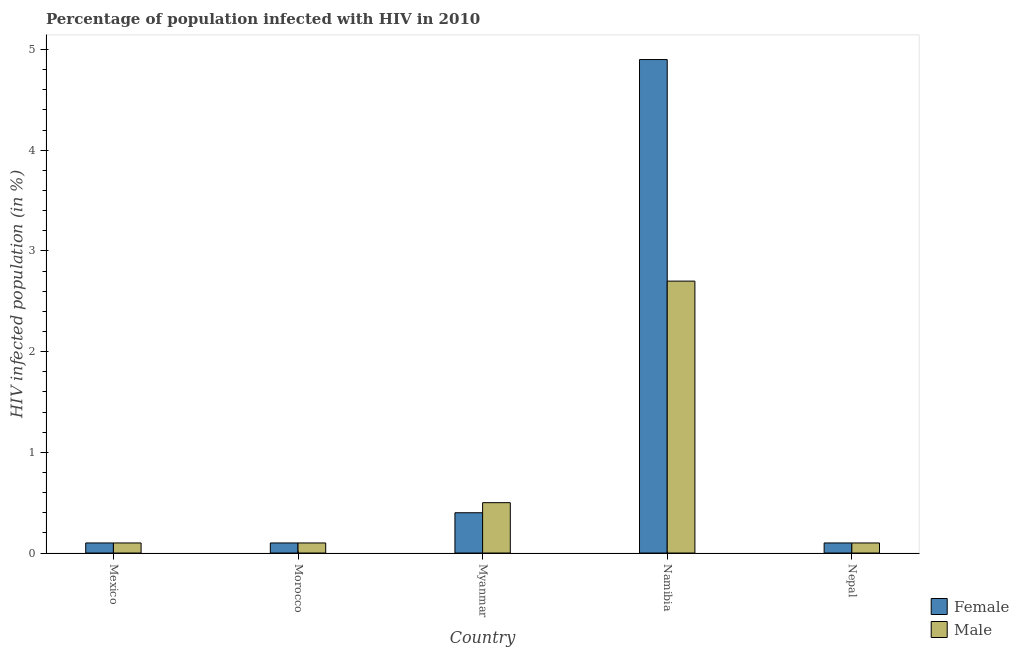How many different coloured bars are there?
Keep it short and to the point. 2. Are the number of bars per tick equal to the number of legend labels?
Your answer should be very brief. Yes. How many bars are there on the 4th tick from the left?
Provide a succinct answer. 2. How many bars are there on the 4th tick from the right?
Ensure brevity in your answer.  2. What is the label of the 4th group of bars from the left?
Offer a very short reply. Namibia. In how many cases, is the number of bars for a given country not equal to the number of legend labels?
Provide a short and direct response. 0. What is the percentage of females who are infected with hiv in Nepal?
Ensure brevity in your answer.  0.1. In which country was the percentage of females who are infected with hiv maximum?
Your response must be concise. Namibia. In which country was the percentage of females who are infected with hiv minimum?
Provide a succinct answer. Mexico. What is the average percentage of males who are infected with hiv per country?
Provide a short and direct response. 0.7. What is the difference between the percentage of females who are infected with hiv and percentage of males who are infected with hiv in Nepal?
Your response must be concise. 0. In how many countries, is the percentage of males who are infected with hiv greater than 0.6000000000000001 %?
Ensure brevity in your answer.  1. What is the ratio of the percentage of females who are infected with hiv in Mexico to that in Nepal?
Provide a short and direct response. 1. Is the difference between the percentage of females who are infected with hiv in Mexico and Morocco greater than the difference between the percentage of males who are infected with hiv in Mexico and Morocco?
Offer a terse response. No. In how many countries, is the percentage of males who are infected with hiv greater than the average percentage of males who are infected with hiv taken over all countries?
Your answer should be compact. 1. How many bars are there?
Your response must be concise. 10. What is the difference between two consecutive major ticks on the Y-axis?
Ensure brevity in your answer.  1. Does the graph contain any zero values?
Provide a succinct answer. No. How many legend labels are there?
Offer a terse response. 2. What is the title of the graph?
Offer a terse response. Percentage of population infected with HIV in 2010. Does "Age 65(male)" appear as one of the legend labels in the graph?
Give a very brief answer. No. What is the label or title of the X-axis?
Keep it short and to the point. Country. What is the label or title of the Y-axis?
Offer a terse response. HIV infected population (in %). What is the HIV infected population (in %) of Female in Mexico?
Your answer should be very brief. 0.1. What is the HIV infected population (in %) of Male in Morocco?
Give a very brief answer. 0.1. What is the HIV infected population (in %) of Female in Myanmar?
Your answer should be compact. 0.4. What is the HIV infected population (in %) in Male in Myanmar?
Your answer should be compact. 0.5. What is the HIV infected population (in %) of Female in Namibia?
Provide a short and direct response. 4.9. What is the HIV infected population (in %) of Male in Nepal?
Offer a terse response. 0.1. Across all countries, what is the maximum HIV infected population (in %) in Female?
Keep it short and to the point. 4.9. Across all countries, what is the maximum HIV infected population (in %) of Male?
Make the answer very short. 2.7. Across all countries, what is the minimum HIV infected population (in %) of Female?
Offer a very short reply. 0.1. What is the total HIV infected population (in %) of Male in the graph?
Keep it short and to the point. 3.5. What is the difference between the HIV infected population (in %) in Male in Mexico and that in Namibia?
Offer a very short reply. -2.6. What is the difference between the HIV infected population (in %) in Male in Mexico and that in Nepal?
Provide a short and direct response. 0. What is the difference between the HIV infected population (in %) of Female in Morocco and that in Myanmar?
Give a very brief answer. -0.3. What is the difference between the HIV infected population (in %) of Male in Morocco and that in Namibia?
Provide a succinct answer. -2.6. What is the difference between the HIV infected population (in %) of Female in Myanmar and that in Namibia?
Offer a very short reply. -4.5. What is the difference between the HIV infected population (in %) in Male in Myanmar and that in Namibia?
Your answer should be very brief. -2.2. What is the difference between the HIV infected population (in %) of Male in Myanmar and that in Nepal?
Your answer should be compact. 0.4. What is the difference between the HIV infected population (in %) of Female in Namibia and that in Nepal?
Your answer should be compact. 4.8. What is the difference between the HIV infected population (in %) of Female in Mexico and the HIV infected population (in %) of Male in Morocco?
Provide a succinct answer. 0. What is the difference between the HIV infected population (in %) in Female in Mexico and the HIV infected population (in %) in Male in Myanmar?
Ensure brevity in your answer.  -0.4. What is the difference between the HIV infected population (in %) of Female in Morocco and the HIV infected population (in %) of Male in Namibia?
Ensure brevity in your answer.  -2.6. What is the difference between the HIV infected population (in %) of Female in Myanmar and the HIV infected population (in %) of Male in Nepal?
Give a very brief answer. 0.3. What is the difference between the HIV infected population (in %) in Female in Namibia and the HIV infected population (in %) in Male in Nepal?
Offer a terse response. 4.8. What is the average HIV infected population (in %) in Female per country?
Your answer should be very brief. 1.12. What is the difference between the HIV infected population (in %) of Female and HIV infected population (in %) of Male in Namibia?
Your answer should be very brief. 2.2. What is the ratio of the HIV infected population (in %) in Male in Mexico to that in Morocco?
Give a very brief answer. 1. What is the ratio of the HIV infected population (in %) in Female in Mexico to that in Myanmar?
Your answer should be compact. 0.25. What is the ratio of the HIV infected population (in %) of Male in Mexico to that in Myanmar?
Make the answer very short. 0.2. What is the ratio of the HIV infected population (in %) of Female in Mexico to that in Namibia?
Offer a terse response. 0.02. What is the ratio of the HIV infected population (in %) in Male in Mexico to that in Namibia?
Make the answer very short. 0.04. What is the ratio of the HIV infected population (in %) in Female in Mexico to that in Nepal?
Ensure brevity in your answer.  1. What is the ratio of the HIV infected population (in %) of Male in Mexico to that in Nepal?
Your response must be concise. 1. What is the ratio of the HIV infected population (in %) of Male in Morocco to that in Myanmar?
Your answer should be compact. 0.2. What is the ratio of the HIV infected population (in %) in Female in Morocco to that in Namibia?
Your response must be concise. 0.02. What is the ratio of the HIV infected population (in %) in Male in Morocco to that in Namibia?
Offer a very short reply. 0.04. What is the ratio of the HIV infected population (in %) of Female in Morocco to that in Nepal?
Your answer should be compact. 1. What is the ratio of the HIV infected population (in %) in Female in Myanmar to that in Namibia?
Offer a very short reply. 0.08. What is the ratio of the HIV infected population (in %) of Male in Myanmar to that in Namibia?
Provide a short and direct response. 0.19. What is the ratio of the HIV infected population (in %) of Male in Myanmar to that in Nepal?
Your answer should be very brief. 5. What is the ratio of the HIV infected population (in %) of Female in Namibia to that in Nepal?
Your answer should be compact. 49. What is the ratio of the HIV infected population (in %) of Male in Namibia to that in Nepal?
Your answer should be compact. 27. What is the difference between the highest and the lowest HIV infected population (in %) in Male?
Ensure brevity in your answer.  2.6. 